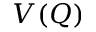Convert formula to latex. <formula><loc_0><loc_0><loc_500><loc_500>V ( Q )</formula> 